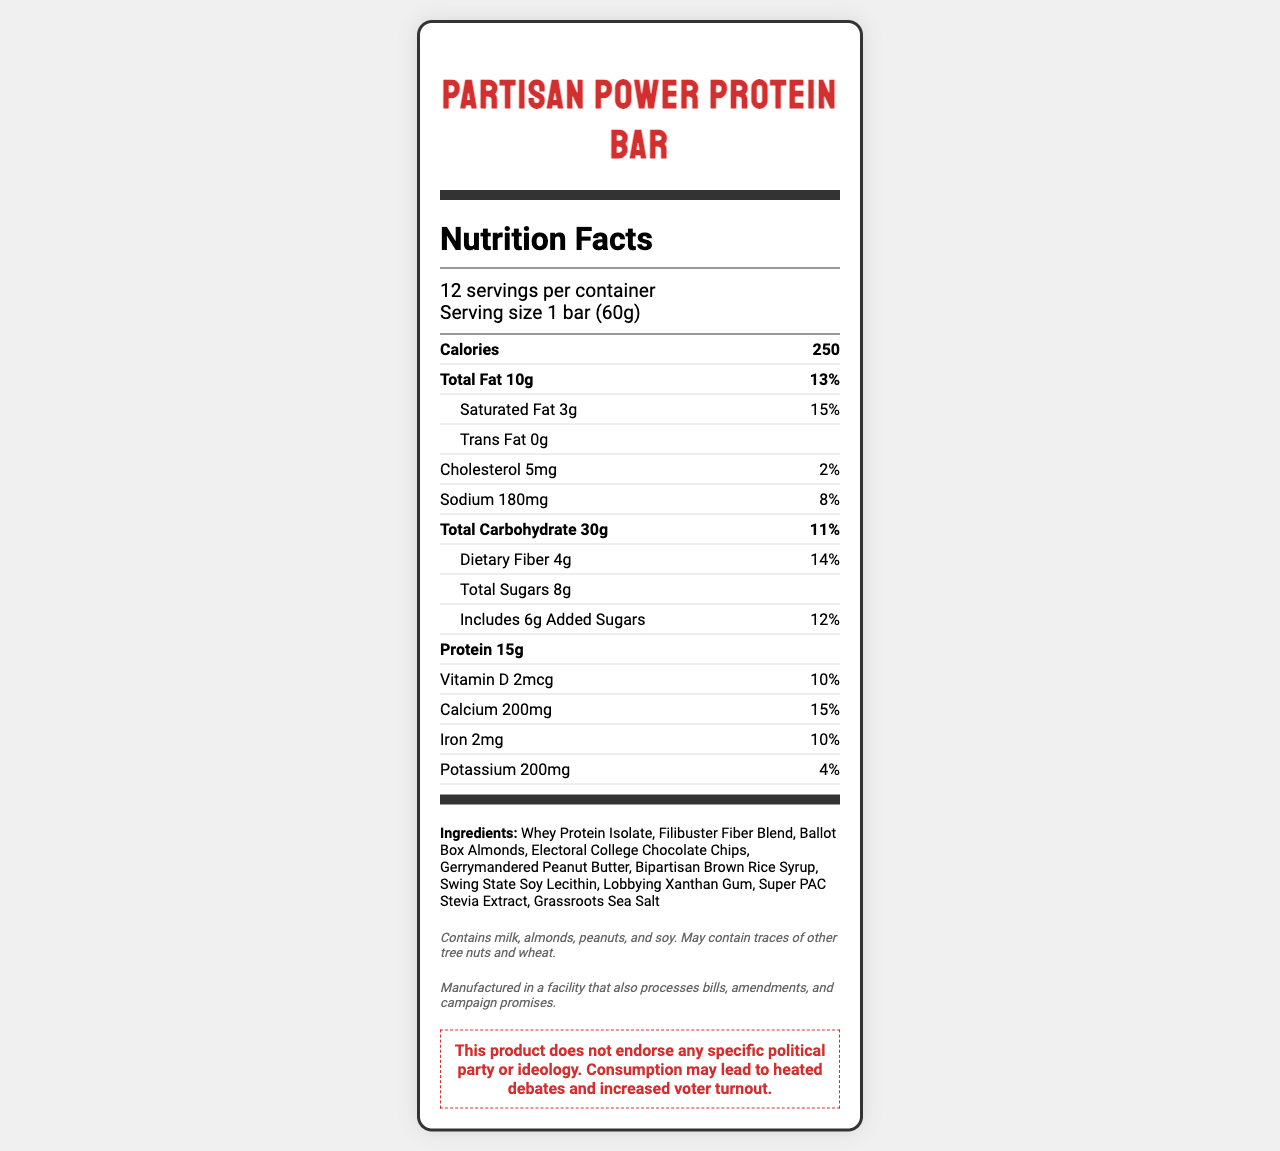who is the intended audience for this product? The product name and ingredient names are politicized, suggesting it is aimed at those who are politically aware or enjoy political jokes.
Answer: People who are interested in political themes and wish to have a protein bar with a touch of humor about politics. what unusual ingredients are included on the label? These ingredient names are unusual because they reference political terms and concepts.
Answer: Filibuster Fiber Blend, Ballot Box Almonds, Electoral College Chocolate Chips, Gerrymandered Peanut Butter, Bipartisan Brown Rice Syrup, Swing State Soy Lecithin, Lobbying Xanthan Gum, Super PAC Stevia Extract, Grassroots Sea Salt how much protein does each bar provide? The protein amount indicated in the document is 15 grams per serving.
Answer: 15g what are the potential allergens listed on the label? The allergen info section states that the product contains milk, almonds, peanuts, and soy.
Answer: Milk, almonds, peanuts, and soy. how many servings are there per container? The serving info section states there are 12 servings per container.
Answer: 12 which amount is higher, total sugars or added sugars? A. Total Sugars B. Added Sugars Total sugars are indicated as 8g, while added sugars are 6g, making total sugars the higher amount.
Answer: A what is the percentage daily value of total fat? A. 10% B. 13% C. 15% D. 20% The document states the total fat amount is 10g, corresponding to 13% of the daily value.
Answer: B is there any trans fat in the bar? The trans fat amount is listed as 0g.
Answer: No describe the main idea of the document. The document includes nutrition facts, a list of ingredients with political themes, allergen information, a manufacturing note, and a political disclaimer.
Answer: The document provides detailed nutritional information for the "Partisan Power Protein Bar", featuring politically humorous ingredient names and a disclaimer that the product does not endorse any political ideology. what is the serving size in grams? The serving size is specified as 1 bar (60g).
Answer: 60g can the exact manufacturing location of the protein bar be determined from the document? The document only mentions that it is manufactured in a facility that also processes bills, amendments, and campaign promises, without giving a specific location.
Answer: Not enough information 